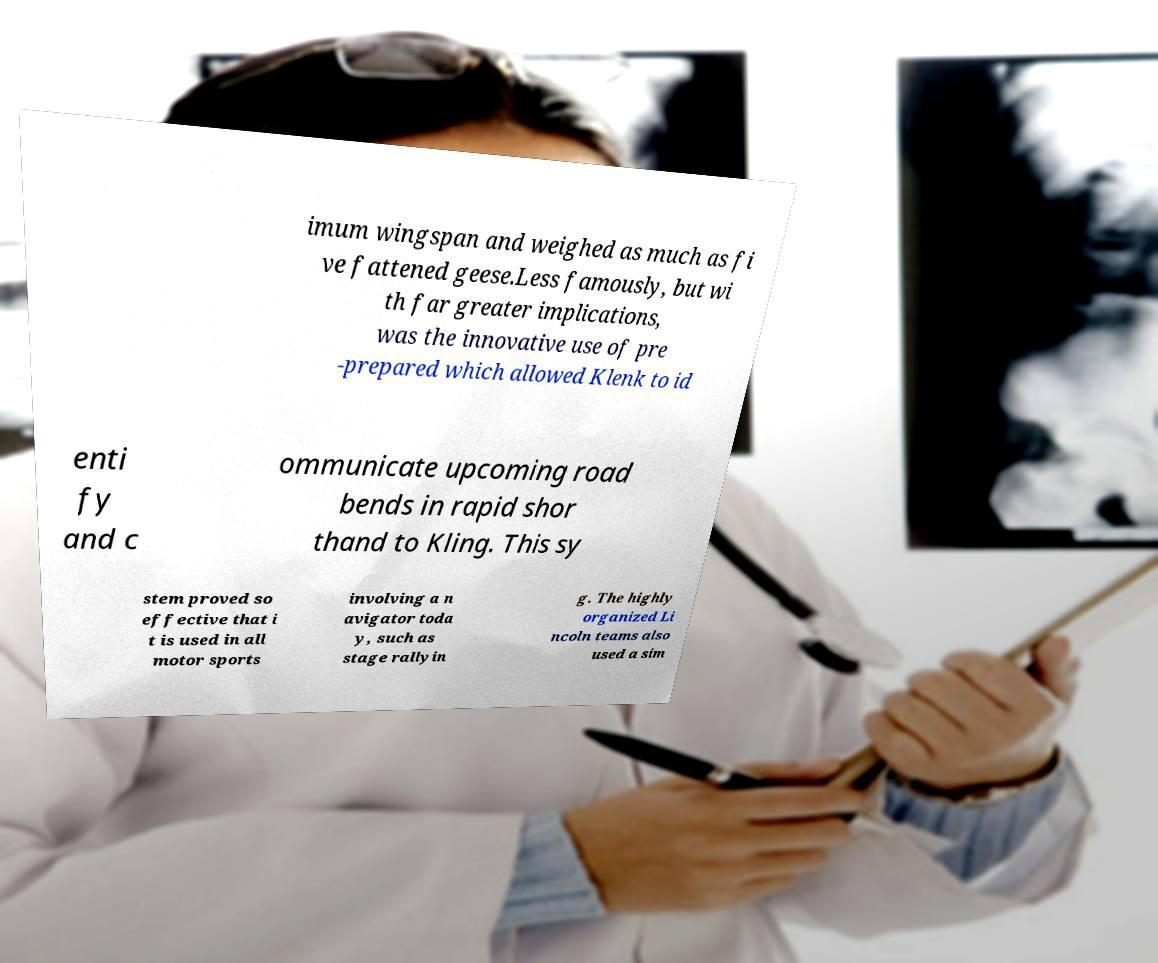Can you accurately transcribe the text from the provided image for me? imum wingspan and weighed as much as fi ve fattened geese.Less famously, but wi th far greater implications, was the innovative use of pre -prepared which allowed Klenk to id enti fy and c ommunicate upcoming road bends in rapid shor thand to Kling. This sy stem proved so effective that i t is used in all motor sports involving a n avigator toda y, such as stage rallyin g. The highly organized Li ncoln teams also used a sim 